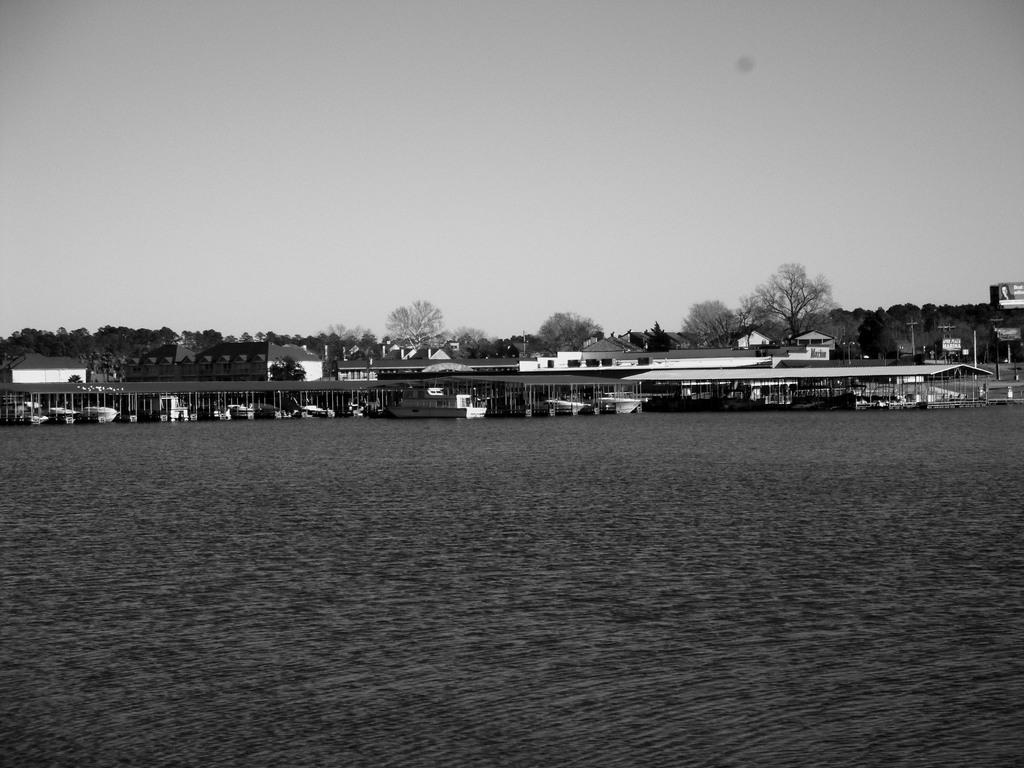What type of structures can be seen near the sea shore in the image? There are houses on the sea shore in the image. What other objects are present near the sea shore? There are boats in the image. What type of vegetation is visible in the image? There are trees visible in the image. What is visible above the sea and houses in the image? The sky is visible in the image. Can you tell me the grade of the mist in the image? There is no mist present in the image; it features houses, boats, trees, and a visible sky. How does the help arrive for the boats in the image? The image does not depict any situation requiring help for the boats, nor does it show any means of assistance. 